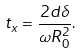Convert formula to latex. <formula><loc_0><loc_0><loc_500><loc_500>t _ { x } = \frac { 2 d \delta } { \omega R _ { 0 } ^ { 2 } } .</formula> 